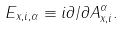<formula> <loc_0><loc_0><loc_500><loc_500>E _ { x , i , \alpha } \equiv i \partial / \partial A _ { x , i } ^ { \alpha } .</formula> 